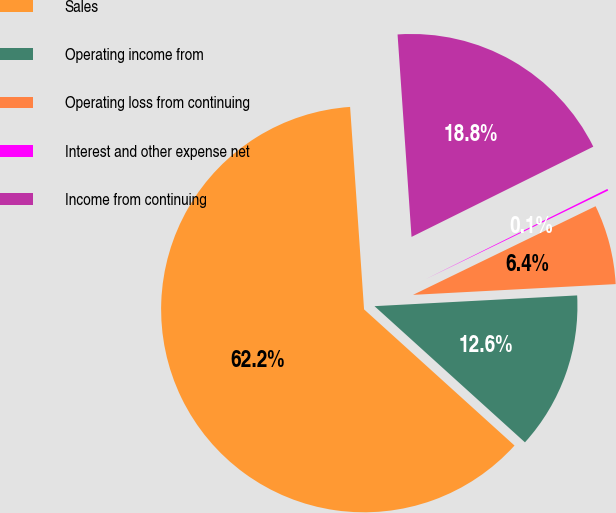<chart> <loc_0><loc_0><loc_500><loc_500><pie_chart><fcel>Sales<fcel>Operating income from<fcel>Operating loss from continuing<fcel>Interest and other expense net<fcel>Income from continuing<nl><fcel>62.19%<fcel>12.55%<fcel>6.35%<fcel>0.14%<fcel>18.76%<nl></chart> 